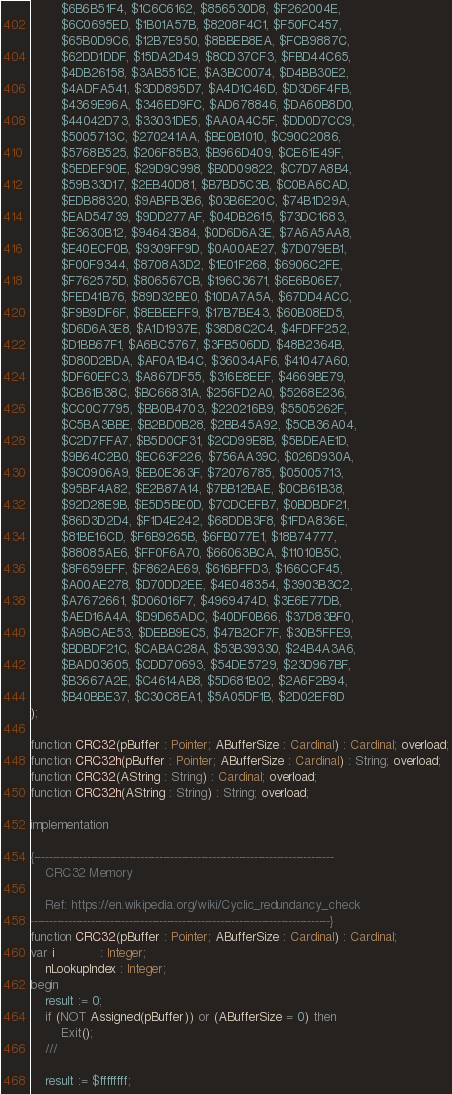Convert code to text. <code><loc_0><loc_0><loc_500><loc_500><_Pascal_>        $6B6B51F4, $1C6C6162, $856530D8, $F262004E,
        $6C0695ED, $1B01A57B, $8208F4C1, $F50FC457,
        $65B0D9C6, $12B7E950, $8BBEB8EA, $FCB9887C,
        $62DD1DDF, $15DA2D49, $8CD37CF3, $FBD44C65,
        $4DB26158, $3AB551CE, $A3BC0074, $D4BB30E2,
        $4ADFA541, $3DD895D7, $A4D1C46D, $D3D6F4FB,
        $4369E96A, $346ED9FC, $AD678846, $DA60B8D0,
        $44042D73, $33031DE5, $AA0A4C5F, $DD0D7CC9,
        $5005713C, $270241AA, $BE0B1010, $C90C2086,
        $5768B525, $206F85B3, $B966D409, $CE61E49F,
        $5EDEF90E, $29D9C998, $B0D09822, $C7D7A8B4,
        $59B33D17, $2EB40D81, $B7BD5C3B, $C0BA6CAD,
        $EDB88320, $9ABFB3B6, $03B6E20C, $74B1D29A,
        $EAD54739, $9DD277AF, $04DB2615, $73DC1683,
        $E3630B12, $94643B84, $0D6D6A3E, $7A6A5AA8,
        $E40ECF0B, $9309FF9D, $0A00AE27, $7D079EB1,
        $F00F9344, $8708A3D2, $1E01F268, $6906C2FE,
        $F762575D, $806567CB, $196C3671, $6E6B06E7,
        $FED41B76, $89D32BE0, $10DA7A5A, $67DD4ACC,
        $F9B9DF6F, $8EBEEFF9, $17B7BE43, $60B08ED5,
        $D6D6A3E8, $A1D1937E, $38D8C2C4, $4FDFF252,
        $D1BB67F1, $A6BC5767, $3FB506DD, $48B2364B,
        $D80D2BDA, $AF0A1B4C, $36034AF6, $41047A60,
        $DF60EFC3, $A867DF55, $316E8EEF, $4669BE79,
        $CB61B38C, $BC66831A, $256FD2A0, $5268E236,
        $CC0C7795, $BB0B4703, $220216B9, $5505262F,
        $C5BA3BBE, $B2BD0B28, $2BB45A92, $5CB36A04,
        $C2D7FFA7, $B5D0CF31, $2CD99E8B, $5BDEAE1D,
        $9B64C2B0, $EC63F226, $756AA39C, $026D930A,
        $9C0906A9, $EB0E363F, $72076785, $05005713,
        $95BF4A82, $E2B87A14, $7BB12BAE, $0CB61B38,
        $92D28E9B, $E5D5BE0D, $7CDCEFB7, $0BDBDF21,
        $86D3D2D4, $F1D4E242, $68DDB3F8, $1FDA836E,
        $81BE16CD, $F6B9265B, $6FB077E1, $18B74777,
        $88085AE6, $FF0F6A70, $66063BCA, $11010B5C,
        $8F659EFF, $F862AE69, $616BFFD3, $166CCF45,
        $A00AE278, $D70DD2EE, $4E048354, $3903B3C2,
        $A7672661, $D06016F7, $4969474D, $3E6E77DB,
        $AED16A4A, $D9D65ADC, $40DF0B66, $37D83BF0,
        $A9BCAE53, $DEBB9EC5, $47B2CF7F, $30B5FFE9,
        $BDBDF21C, $CABAC28A, $53B39330, $24B4A3A6,
        $BAD03605, $CDD70693, $54DE5729, $23D967BF,
        $B3667A2E, $C4614AB8, $5D681B02, $2A6F2B94,
        $B40BBE37, $C30C8EA1, $5A05DF1B, $2D02EF8D
);

function CRC32(pBuffer : Pointer; ABufferSize : Cardinal) : Cardinal; overload;
function CRC32h(pBuffer : Pointer; ABufferSize : Cardinal) : String; overload;
function CRC32(AString : String) : Cardinal; overload;
function CRC32h(AString : String) : String; overload;

implementation

{-------------------------------------------------------------------------------
    CRC32 Memory

    Ref: https://en.wikipedia.org/wiki/Cyclic_redundancy_check
-------------------------------------------------------------------------------}
function CRC32(pBuffer : Pointer; ABufferSize : Cardinal) : Cardinal;
var i            : Integer;
    nLookupIndex : Integer;
begin
    result := 0;
    if (NOT Assigned(pBuffer)) or (ABufferSize = 0) then
        Exit();
    ///

    result := $ffffffff;</code> 